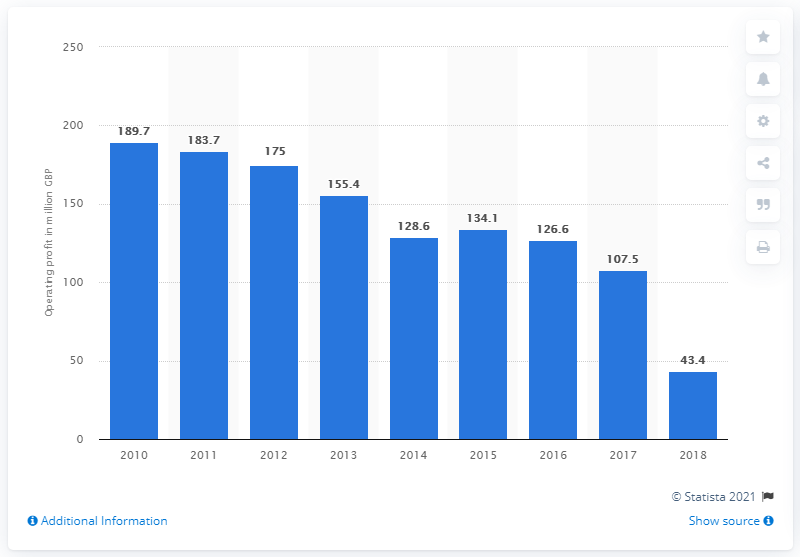Draw attention to some important aspects in this diagram. During the year ending September 1st, 2018, Debenhams' operating profit was 43.4%. 